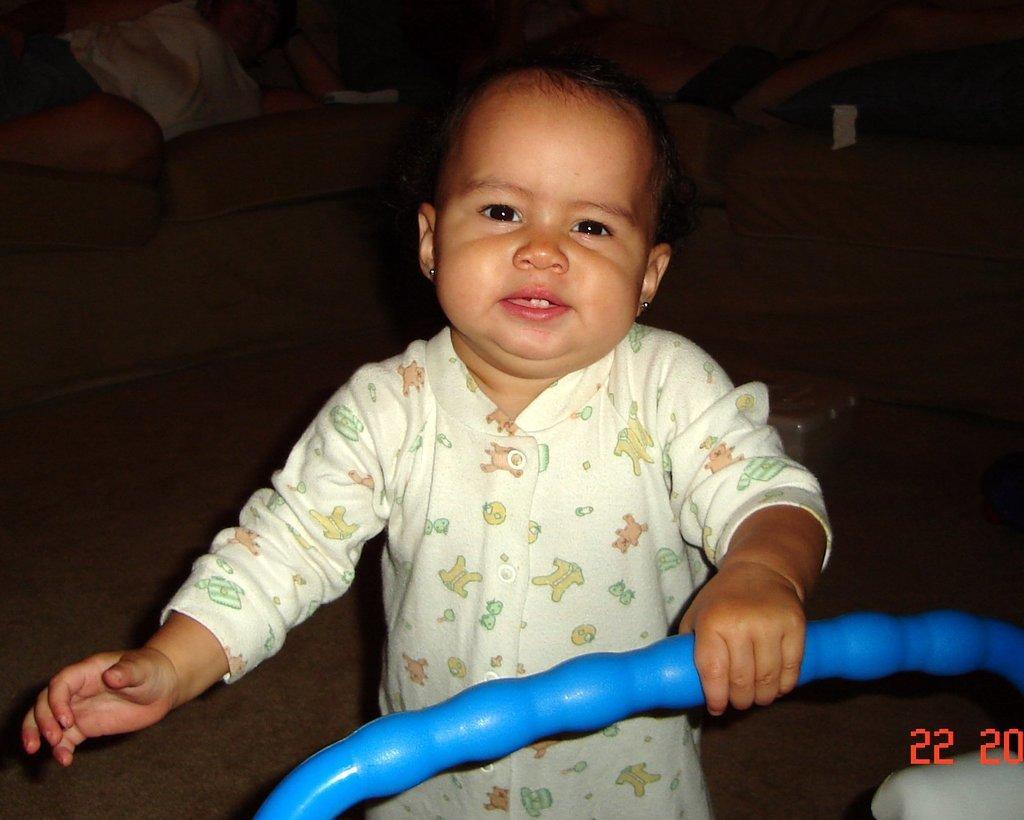Describe this image in one or two sentences. This picture is clicked inside. In the center there is a kid wearing a white color dress, holding a blue color object and standing on the ground. In the background we can see there are some items placed on the ground. At the bottom right corner we can see the numbers on the image. 